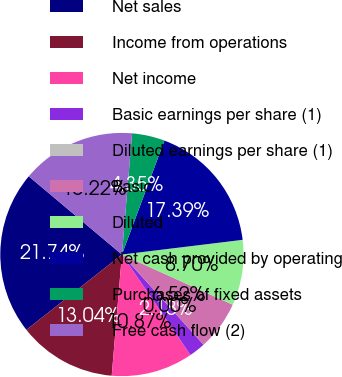<chart> <loc_0><loc_0><loc_500><loc_500><pie_chart><fcel>Net sales<fcel>Income from operations<fcel>Net income<fcel>Basic earnings per share (1)<fcel>Diluted earnings per share (1)<fcel>Basic<fcel>Diluted<fcel>Net cash provided by operating<fcel>Purchases of fixed assets<fcel>Free cash flow (2)<nl><fcel>21.74%<fcel>13.04%<fcel>10.87%<fcel>2.18%<fcel>0.0%<fcel>6.52%<fcel>8.7%<fcel>17.39%<fcel>4.35%<fcel>15.22%<nl></chart> 